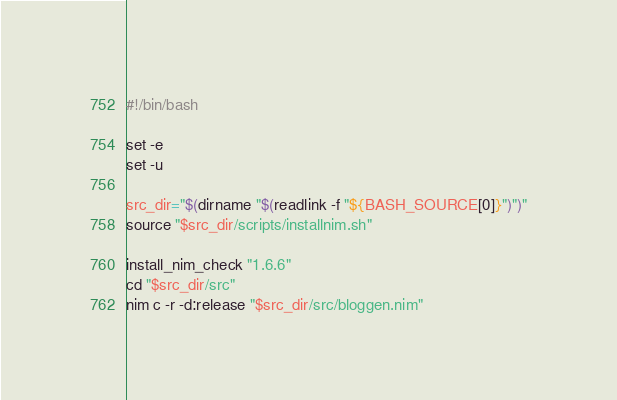Convert code to text. <code><loc_0><loc_0><loc_500><loc_500><_Bash_>#!/bin/bash

set -e
set -u

src_dir="$(dirname "$(readlink -f "${BASH_SOURCE[0]}")")"
source "$src_dir/scripts/installnim.sh"

install_nim_check "1.6.6"
cd "$src_dir/src"
nim c -r -d:release "$src_dir/src/bloggen.nim"
</code> 